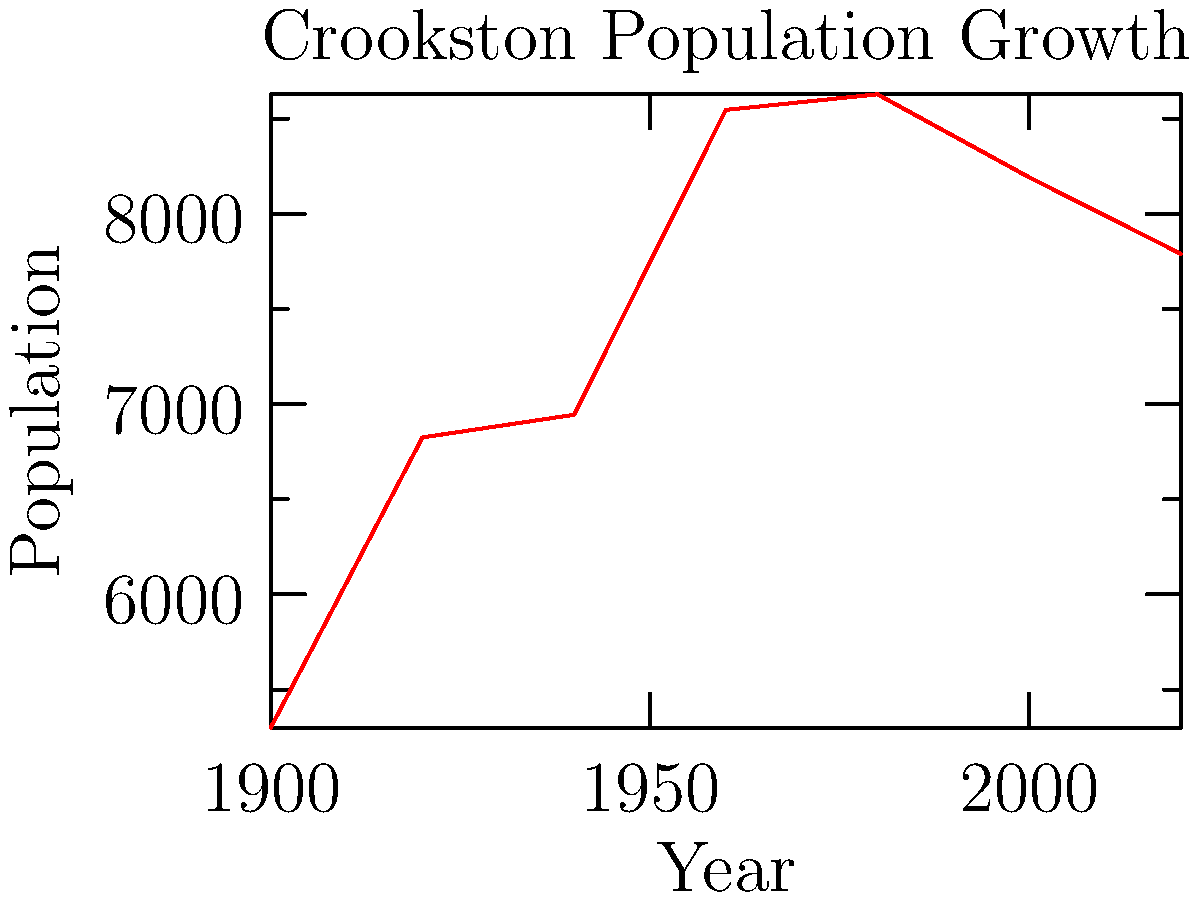Based on the line graph showing Crookston's population growth from 1900 to 2020, in which period did the city experience its most significant population increase? To determine the period of most significant population growth, we need to analyze the slope of the line between each pair of data points:

1. 1900-1920: Increase from 5,300 to 6,825 (1,525 growth)
2. 1920-1940: Increase from 6,825 to 6,944 (119 growth)
3. 1940-1960: Increase from 6,944 to 8,546 (1,602 growth)
4. 1960-1980: Increase from 8,546 to 8,628 (82 growth)
5. 1980-2000: Decrease from 8,628 to 8,192 (negative growth)
6. 2000-2020: Decrease from 8,192 to 7,790 (negative growth)

The steepest upward slope, indicating the most significant population increase, occurs between 1940 and 1960, with a growth of 1,602 people.
Answer: 1940-1960 